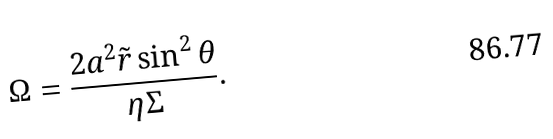<formula> <loc_0><loc_0><loc_500><loc_500>\Omega = \frac { 2 a ^ { 2 } \tilde { r } \sin ^ { 2 } \theta } { \eta \Sigma } .</formula> 